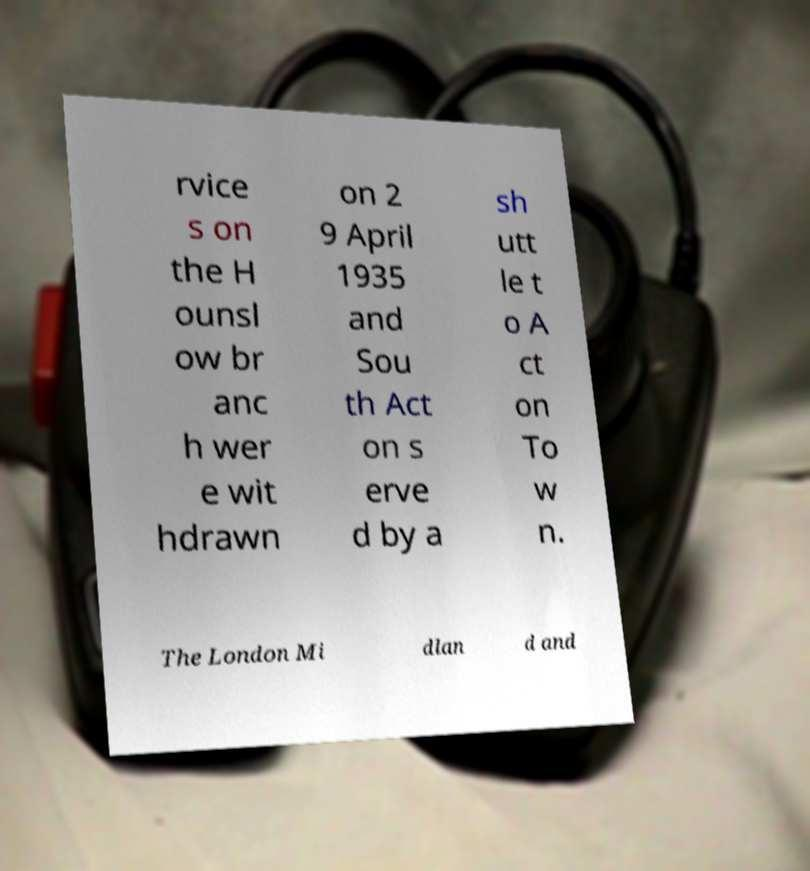What messages or text are displayed in this image? I need them in a readable, typed format. rvice s on the H ounsl ow br anc h wer e wit hdrawn on 2 9 April 1935 and Sou th Act on s erve d by a sh utt le t o A ct on To w n. The London Mi dlan d and 